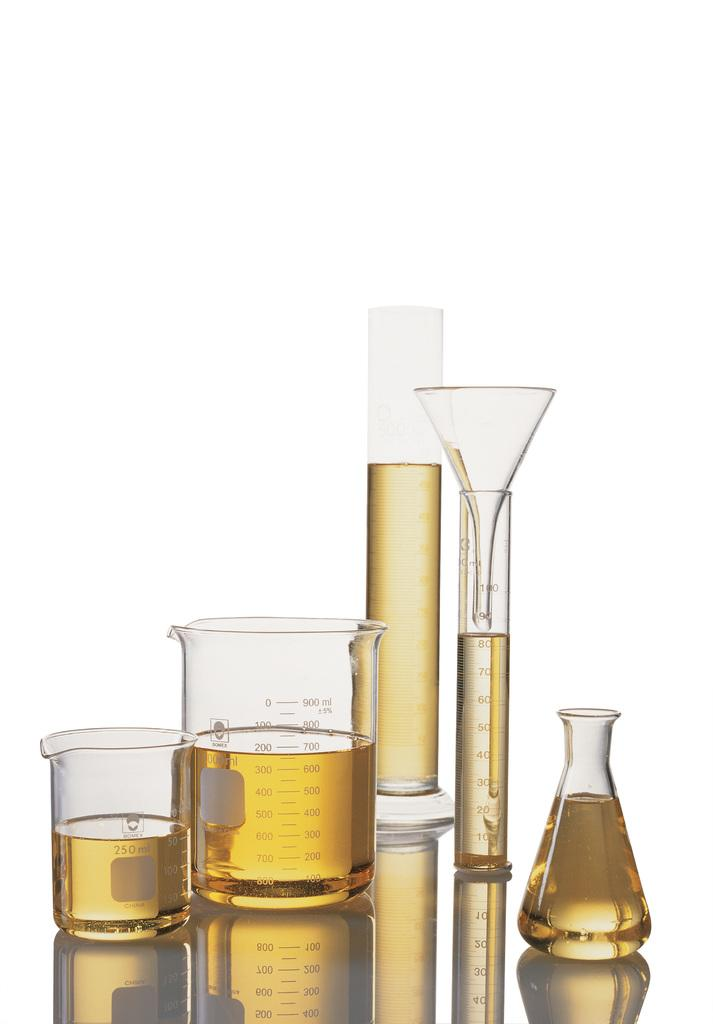<image>
Present a compact description of the photo's key features. A collection of chemistry vials, flasks and beakers is made by Bomex. 